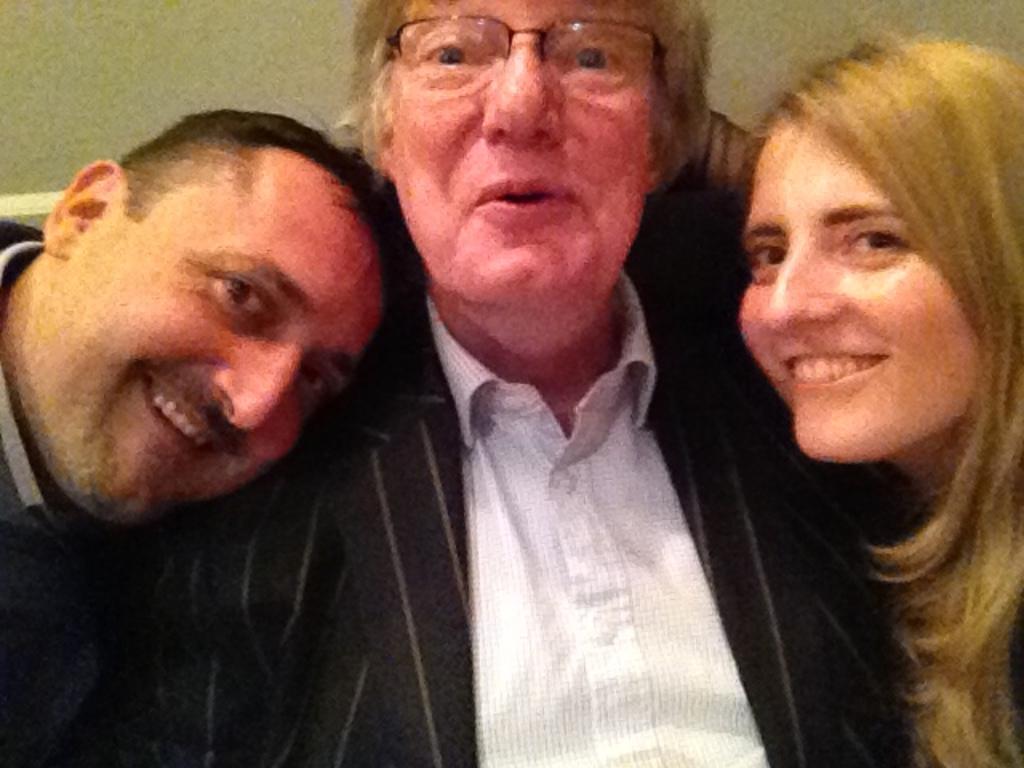Please provide a concise description of this image. In this image we can see three people smiling, among them one person is wearing the spectacles and in the background we can see the wall. 